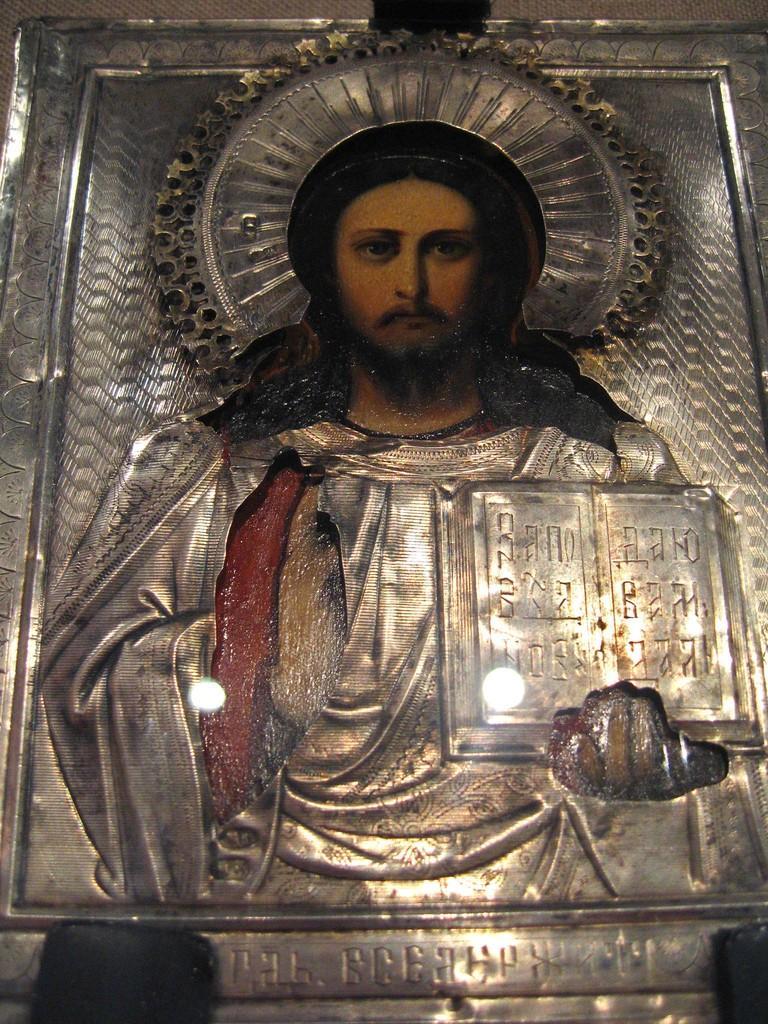Please provide a concise description of this image. In this image, we can see a metal carving and person. On the right side and bottom of the image, we can see some text. 